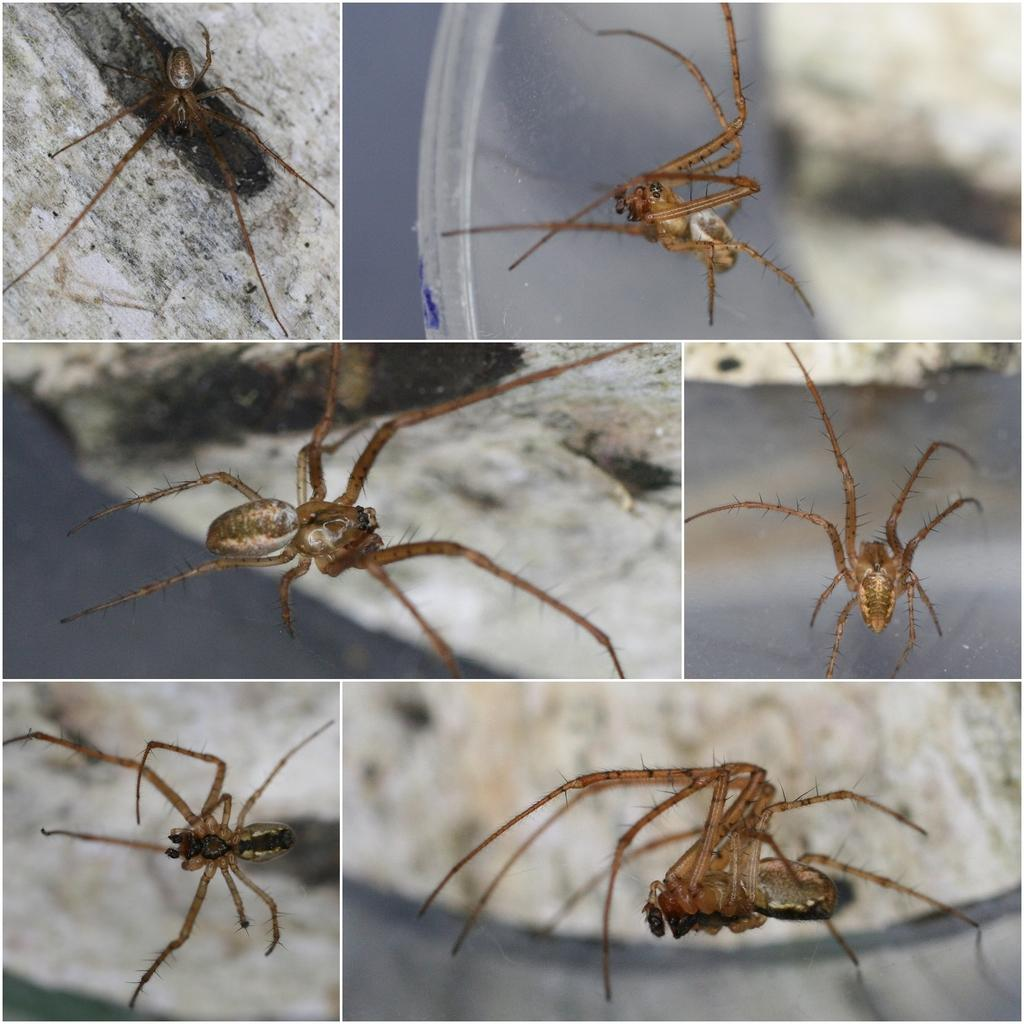What is the main subject of the image? There is a spider in the image. Where is the spider located? The spider is on a path. How is the image presented? The image is a collage with different angles. What is the spider writing on the path in the image? There is no indication that the spider is writing anything in the image. 